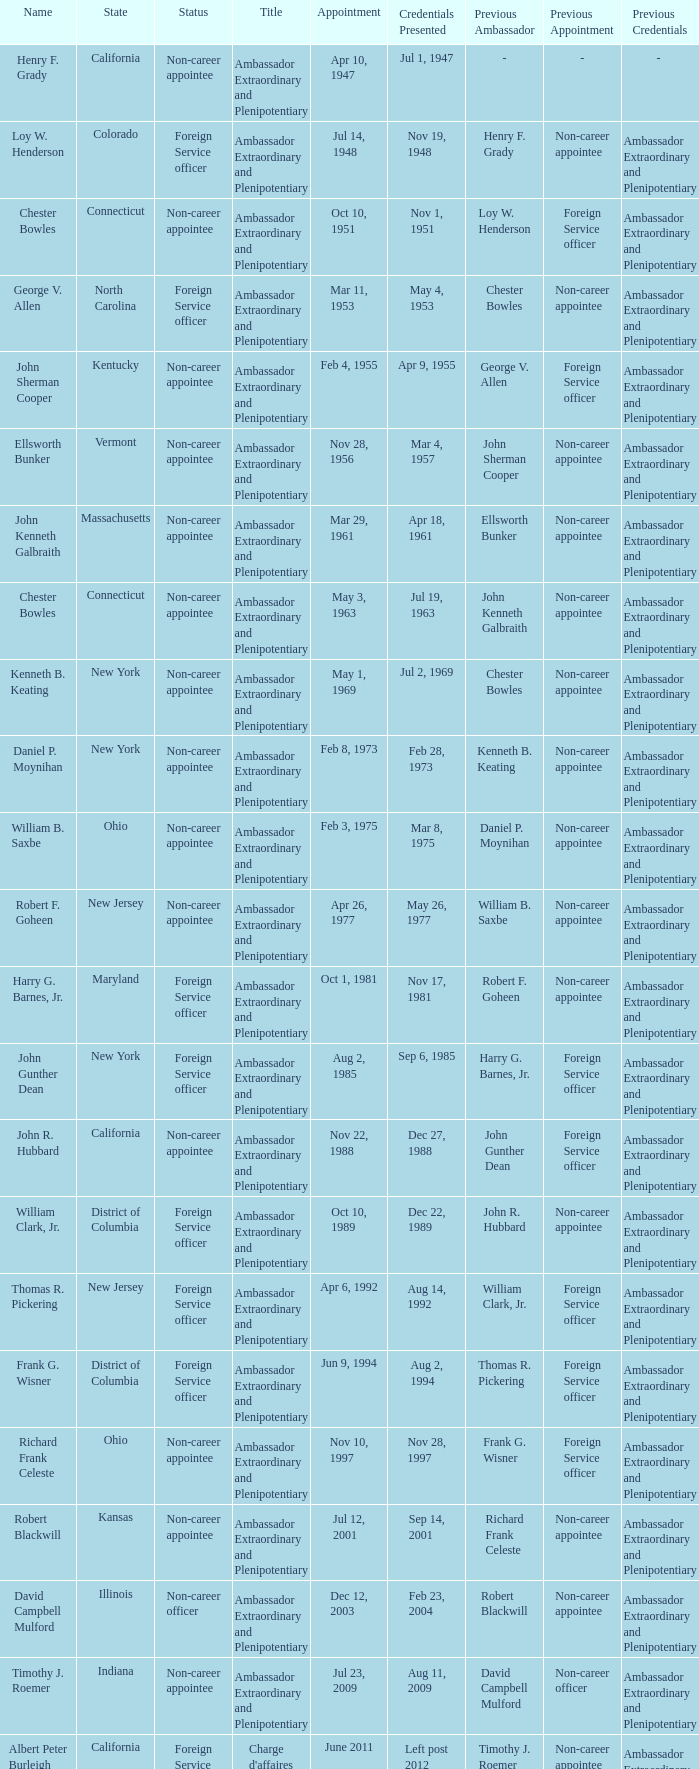What state has an appointment for jul 12, 2001? Kansas. 